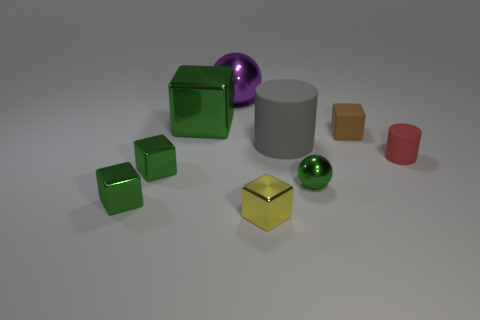How many small objects are gray rubber cylinders or green shiny objects?
Your answer should be very brief. 3. Is the number of gray rubber things greater than the number of small purple rubber blocks?
Make the answer very short. Yes. Is the tiny yellow object made of the same material as the large purple sphere?
Provide a short and direct response. Yes. Is there any other thing that has the same material as the big ball?
Give a very brief answer. Yes. Is the number of brown matte cubes behind the large green shiny thing greater than the number of tiny rubber cylinders?
Make the answer very short. No. Do the large block and the large metal ball have the same color?
Offer a terse response. No. What number of big purple shiny things have the same shape as the brown matte object?
Your answer should be compact. 0. There is a green sphere that is made of the same material as the yellow block; what size is it?
Your answer should be compact. Small. The large thing that is both in front of the large purple object and behind the brown rubber block is what color?
Provide a succinct answer. Green. How many metallic objects are the same size as the brown rubber cube?
Offer a terse response. 4. 